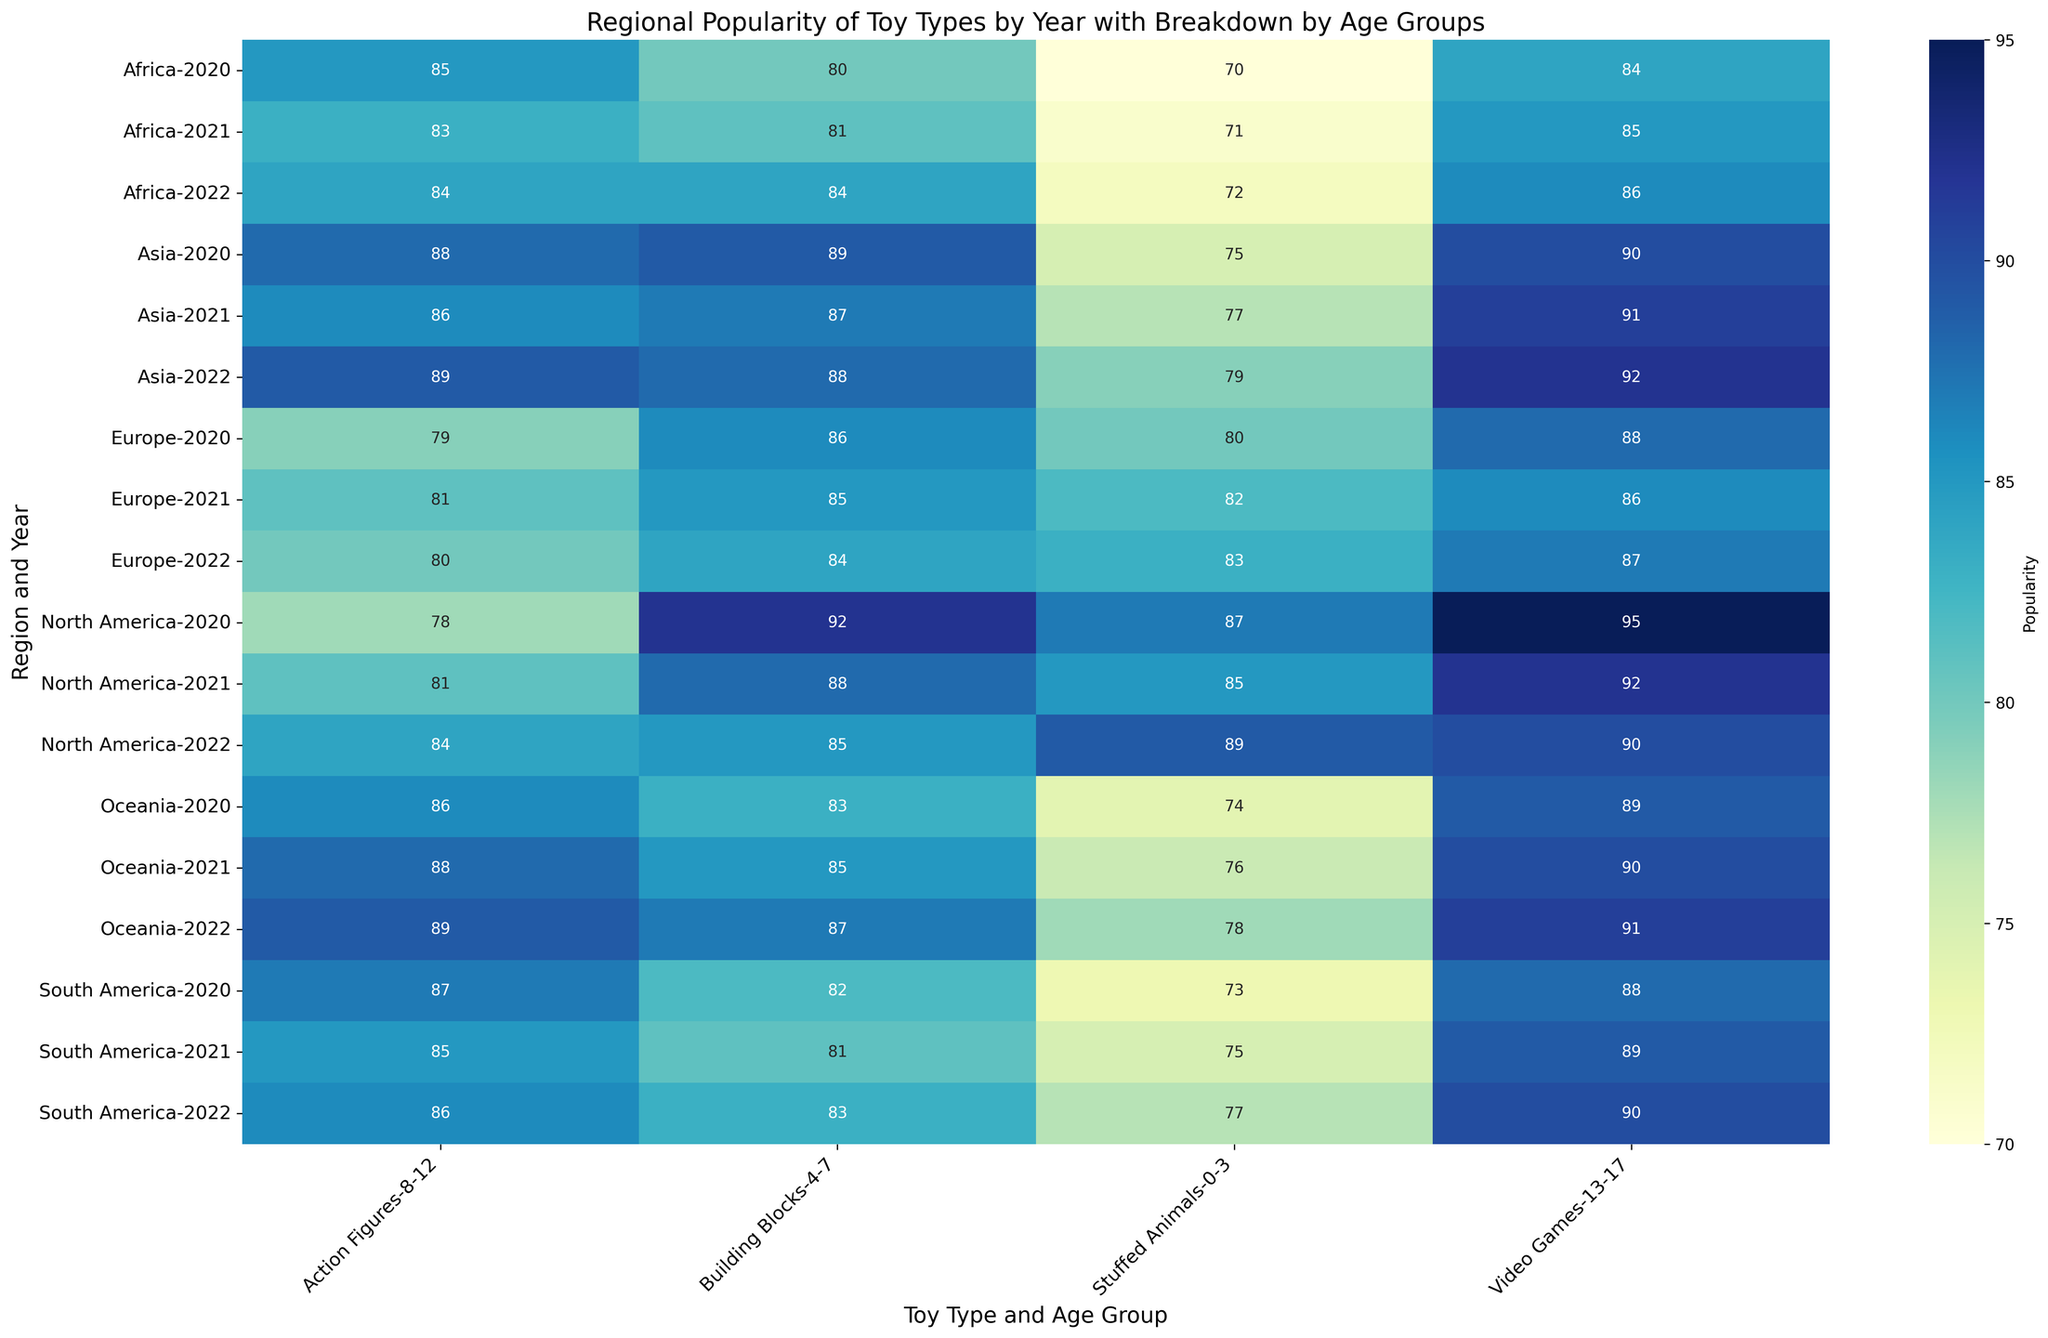Which region had the highest popularity for Stuffed Animals in 2022? To find this answer, look for the intersection of "Stuffed Animals" and "0-3" in the year 2022 across all regions and identify the highest value.
Answer: North America How did the popularity of Action Figures change in North America from 2020 to 2022 for the 8-12 age group? Look for the values of "Action Figures" under "8-12" in North America for the years 2020, 2021, and 2022. The values are 78 (2020), 81 (2021), and 84 (2022). Compute the difference between each year.
Answer: Increased by 6 Which age group in Europe had the highest popularity for Video Games in 2022? Identify the values of "Video Games" in all age groups in 2022 for Europe and determine which age group has the highest value.
Answer: 13-17 What is the combined popularity of Building Blocks in Asia and South America for 2021 among the 4-7 age group? Locate the values for "Building Blocks" under "4-7" for Asia and South America in 2021. The values are 87 (Asia) and 81 (South America). Sum them up: 87 + 81.
Answer: 168 Did the popularity of Stuffed Animals in Oceania for the 0-3 age group increase or decrease from 2020 to 2021? Identify the values for "Stuffed Animals" under "0-3" in Oceania for the years 2020 and 2021. Compare 74 (2020) with 76 (2021).
Answer: Increased Which region had the least popularity for Video Games in 2020 among the 13-17 age group? Compare the values of "Video Games" under "13-17" across all regions for the year 2020 and identify the smallest value.
Answer: Africa What is the overall average popularity of Action Figures in 2022 for all regions among the 8-12 age group? Find the values for "Action Figures" under "8-12" for all regions in 2022. The values are 84 (North America), 80 (Europe), 89 (Asia), 86 (South America), 84 (Africa), 89 (Oceania). Sum them: 84 + 80 + 89 + 86 + 84 + 89 = 512. Divide by the number of values (6): 512/6.
Answer: 85.33 Compare the popularity of Building Blocks in Africa for 2022 with that in Oceania for the same year among the 4-7 age group. Which is higher? Identify the values for "Building Blocks" under "4-7" in Africa and Oceania for 2022. Compare 84 (Africa) with 87 (Oceania).
Answer: Oceania 